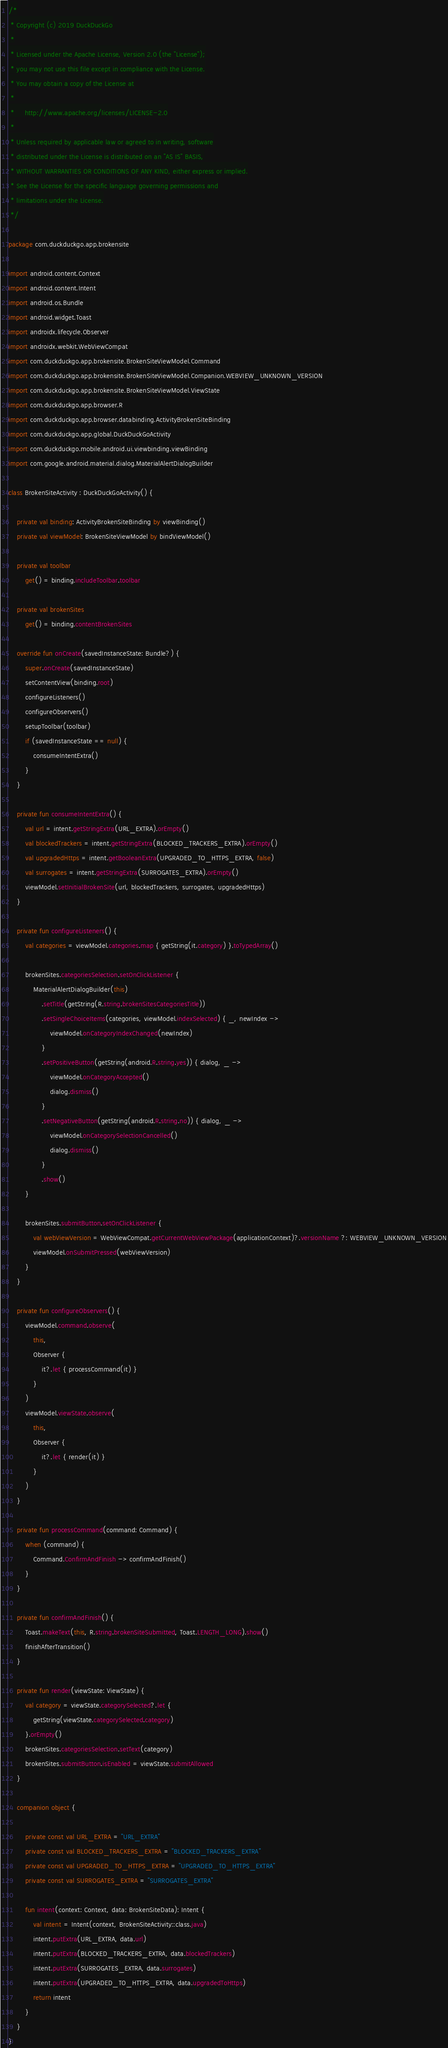Convert code to text. <code><loc_0><loc_0><loc_500><loc_500><_Kotlin_>/*
 * Copyright (c) 2019 DuckDuckGo
 *
 * Licensed under the Apache License, Version 2.0 (the "License");
 * you may not use this file except in compliance with the License.
 * You may obtain a copy of the License at
 *
 *     http://www.apache.org/licenses/LICENSE-2.0
 *
 * Unless required by applicable law or agreed to in writing, software
 * distributed under the License is distributed on an "AS IS" BASIS,
 * WITHOUT WARRANTIES OR CONDITIONS OF ANY KIND, either express or implied.
 * See the License for the specific language governing permissions and
 * limitations under the License.
 */

package com.duckduckgo.app.brokensite

import android.content.Context
import android.content.Intent
import android.os.Bundle
import android.widget.Toast
import androidx.lifecycle.Observer
import androidx.webkit.WebViewCompat
import com.duckduckgo.app.brokensite.BrokenSiteViewModel.Command
import com.duckduckgo.app.brokensite.BrokenSiteViewModel.Companion.WEBVIEW_UNKNOWN_VERSION
import com.duckduckgo.app.brokensite.BrokenSiteViewModel.ViewState
import com.duckduckgo.app.browser.R
import com.duckduckgo.app.browser.databinding.ActivityBrokenSiteBinding
import com.duckduckgo.app.global.DuckDuckGoActivity
import com.duckduckgo.mobile.android.ui.viewbinding.viewBinding
import com.google.android.material.dialog.MaterialAlertDialogBuilder

class BrokenSiteActivity : DuckDuckGoActivity() {

    private val binding: ActivityBrokenSiteBinding by viewBinding()
    private val viewModel: BrokenSiteViewModel by bindViewModel()

    private val toolbar
        get() = binding.includeToolbar.toolbar

    private val brokenSites
        get() = binding.contentBrokenSites

    override fun onCreate(savedInstanceState: Bundle?) {
        super.onCreate(savedInstanceState)
        setContentView(binding.root)
        configureListeners()
        configureObservers()
        setupToolbar(toolbar)
        if (savedInstanceState == null) {
            consumeIntentExtra()
        }
    }

    private fun consumeIntentExtra() {
        val url = intent.getStringExtra(URL_EXTRA).orEmpty()
        val blockedTrackers = intent.getStringExtra(BLOCKED_TRACKERS_EXTRA).orEmpty()
        val upgradedHttps = intent.getBooleanExtra(UPGRADED_TO_HTTPS_EXTRA, false)
        val surrogates = intent.getStringExtra(SURROGATES_EXTRA).orEmpty()
        viewModel.setInitialBrokenSite(url, blockedTrackers, surrogates, upgradedHttps)
    }

    private fun configureListeners() {
        val categories = viewModel.categories.map { getString(it.category) }.toTypedArray()

        brokenSites.categoriesSelection.setOnClickListener {
            MaterialAlertDialogBuilder(this)
                .setTitle(getString(R.string.brokenSitesCategoriesTitle))
                .setSingleChoiceItems(categories, viewModel.indexSelected) { _, newIndex ->
                    viewModel.onCategoryIndexChanged(newIndex)
                }
                .setPositiveButton(getString(android.R.string.yes)) { dialog, _ ->
                    viewModel.onCategoryAccepted()
                    dialog.dismiss()
                }
                .setNegativeButton(getString(android.R.string.no)) { dialog, _ ->
                    viewModel.onCategorySelectionCancelled()
                    dialog.dismiss()
                }
                .show()
        }

        brokenSites.submitButton.setOnClickListener {
            val webViewVersion = WebViewCompat.getCurrentWebViewPackage(applicationContext)?.versionName ?: WEBVIEW_UNKNOWN_VERSION
            viewModel.onSubmitPressed(webViewVersion)
        }
    }

    private fun configureObservers() {
        viewModel.command.observe(
            this,
            Observer {
                it?.let { processCommand(it) }
            }
        )
        viewModel.viewState.observe(
            this,
            Observer {
                it?.let { render(it) }
            }
        )
    }

    private fun processCommand(command: Command) {
        when (command) {
            Command.ConfirmAndFinish -> confirmAndFinish()
        }
    }

    private fun confirmAndFinish() {
        Toast.makeText(this, R.string.brokenSiteSubmitted, Toast.LENGTH_LONG).show()
        finishAfterTransition()
    }

    private fun render(viewState: ViewState) {
        val category = viewState.categorySelected?.let {
            getString(viewState.categorySelected.category)
        }.orEmpty()
        brokenSites.categoriesSelection.setText(category)
        brokenSites.submitButton.isEnabled = viewState.submitAllowed
    }

    companion object {

        private const val URL_EXTRA = "URL_EXTRA"
        private const val BLOCKED_TRACKERS_EXTRA = "BLOCKED_TRACKERS_EXTRA"
        private const val UPGRADED_TO_HTTPS_EXTRA = "UPGRADED_TO_HTTPS_EXTRA"
        private const val SURROGATES_EXTRA = "SURROGATES_EXTRA"

        fun intent(context: Context, data: BrokenSiteData): Intent {
            val intent = Intent(context, BrokenSiteActivity::class.java)
            intent.putExtra(URL_EXTRA, data.url)
            intent.putExtra(BLOCKED_TRACKERS_EXTRA, data.blockedTrackers)
            intent.putExtra(SURROGATES_EXTRA, data.surrogates)
            intent.putExtra(UPGRADED_TO_HTTPS_EXTRA, data.upgradedToHttps)
            return intent
        }
    }
}
</code> 